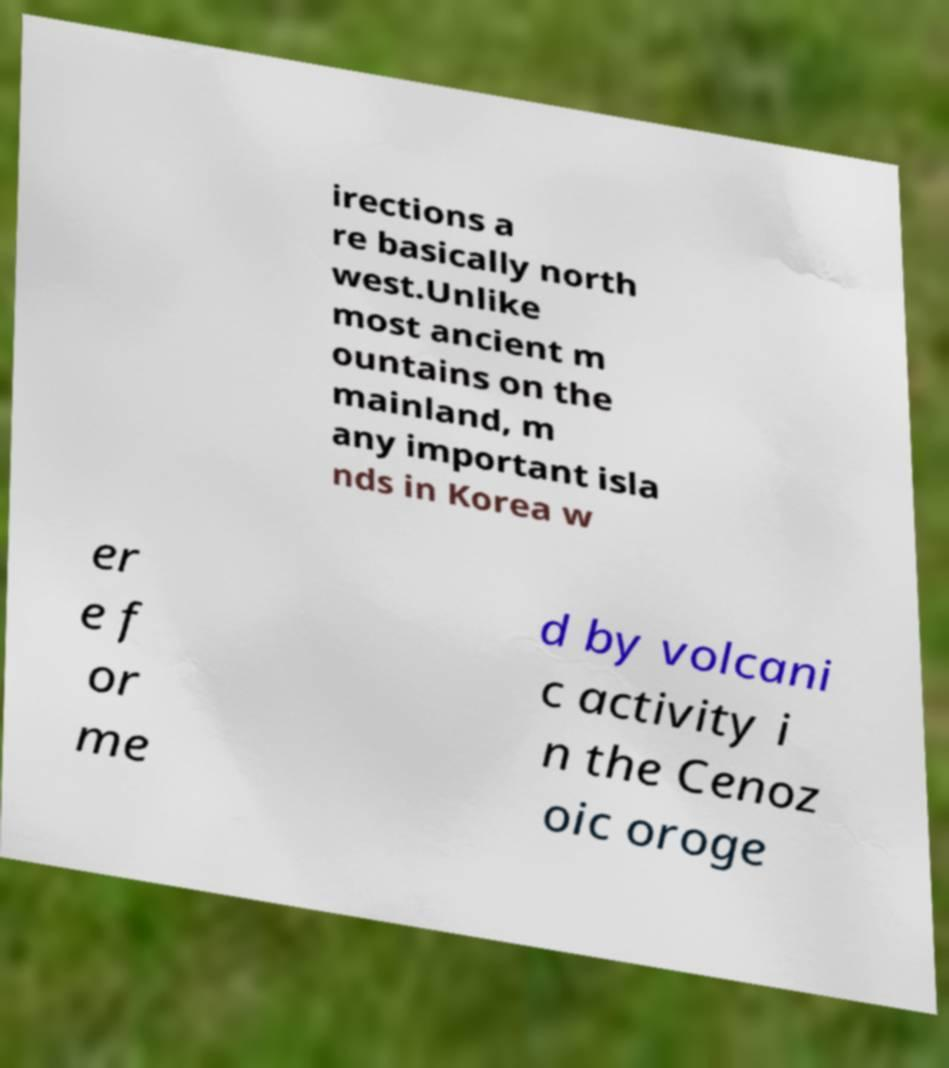Can you accurately transcribe the text from the provided image for me? irections a re basically north west.Unlike most ancient m ountains on the mainland, m any important isla nds in Korea w er e f or me d by volcani c activity i n the Cenoz oic oroge 